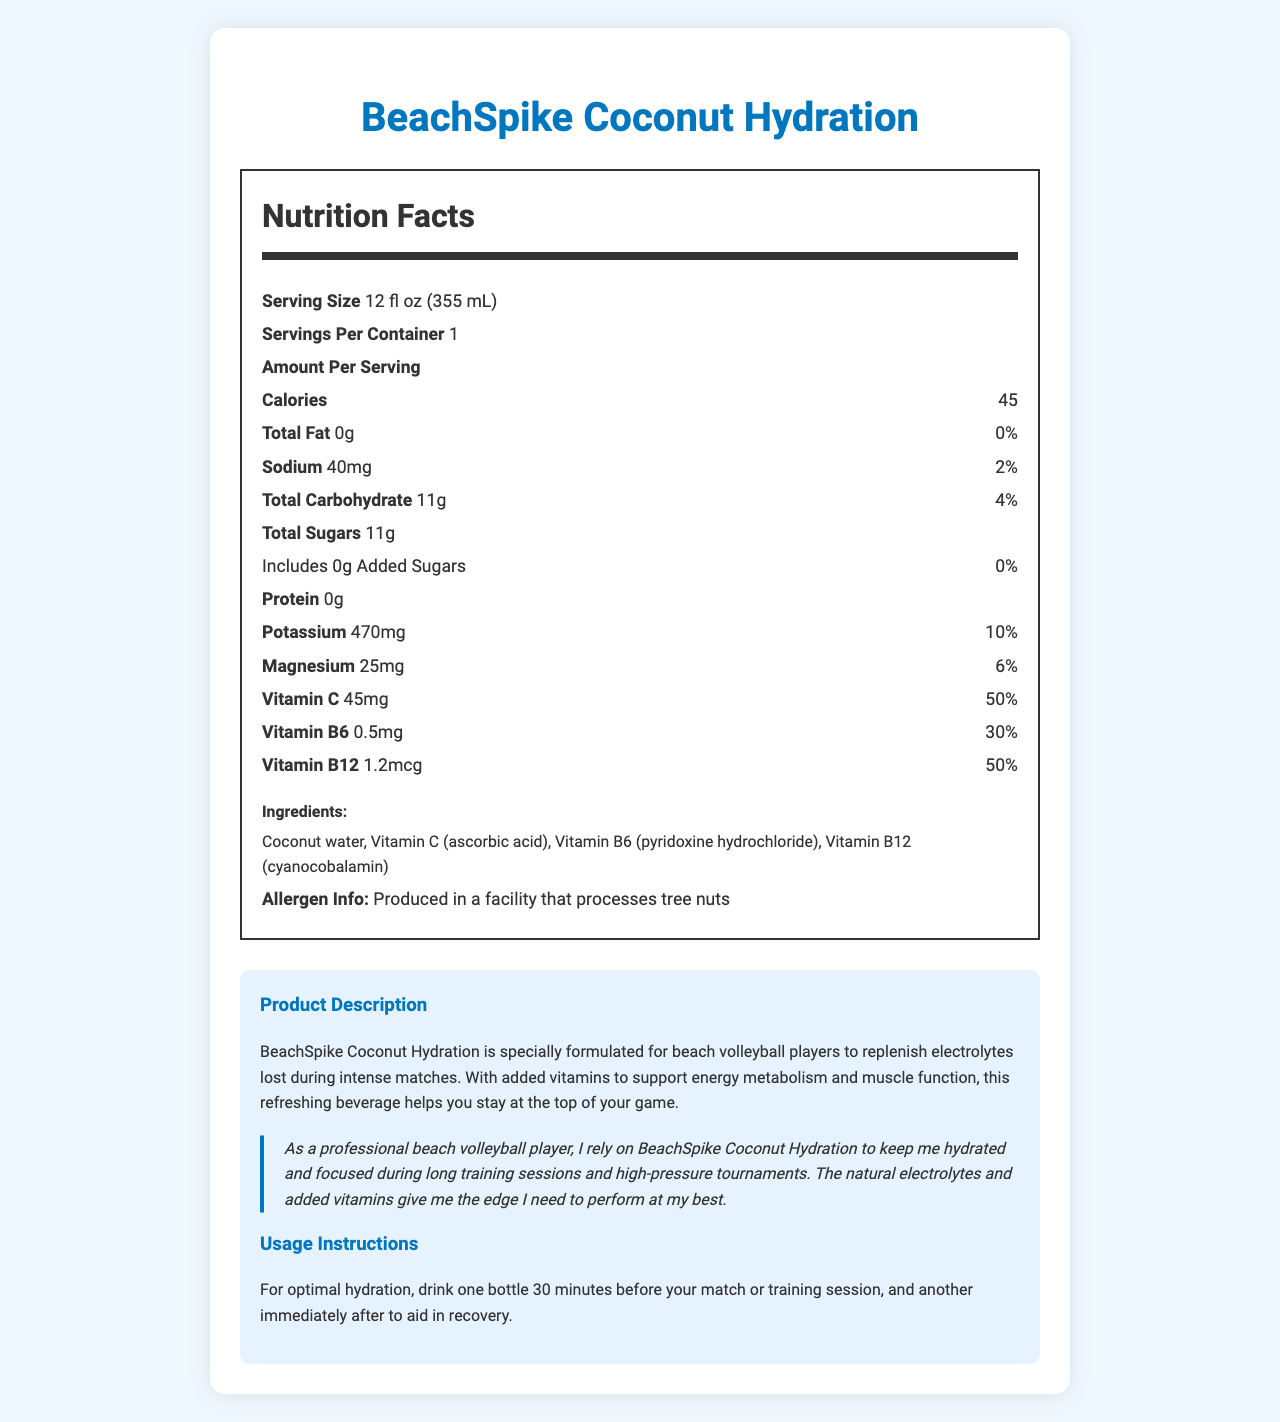what is the serving size? The serving size is listed near the top of the nutrition facts under the heading "Serving Size."
Answer: 12 fl oz (355 mL) how many servings are in one container? The number of servings per container is specified below the serving size, labeled as "Servings Per Container."
Answer: 1 what is the calorie count per serving? The calorie count per serving is clearly indicated just below the "Amount Per Serving" line, labeled as "Calories."
Answer: 45 calories what vitamins are included in this beverage? The vitamins included are listed under the nutrition facts section, with their respective amounts and daily values.
Answer: Vitamin C, Vitamin B6, Vitamin B12 how much sodium is in one serving? The amount of sodium in one serving is noted after the "Sodium" label in the nutrition facts section.
Answer: 40mg how much potassium is there per serving? The amount of potassium is specified next to "Potassium" under the nutrition facts, along with its daily value percentage.
Answer: 470mg what is the total carbohydrate amount per serving? A. 8g B. 10g C. 11g D. 12g The total carbohydrate amount per serving is listed as "Total Carbohydrate" in the nutrition facts section, showing 11g.
Answer: C. 11g what percentage of the daily recommended intake of Vitamin C does this beverage provide? A. 10% B. 25% C. 50% D. 75% The document lists Vitamin C with an amount of 45mg and a daily value of 50%.
Answer: C. 50% can individuals who are allergic to tree nuts consume this product safely? The product is produced in a facility that processes tree nuts, posing a potential risk of cross-contamination for people with tree nut allergies.
Answer: No what is the main purpose of this product? The product is described as being specially formulated for beach volleyball players to replenish electrolytes lost during intense matches and to support energy metabolism and muscle function.
Answer: Hydration and replenishing electrolytes for beach volleyball players does this beverage contain any added sugars? The nutrition facts indicate 0 grams of added sugars under the "Total Sugars" section.
Answer: No how much protein is in one serving of this beverage? The amount of protein per serving is listed as "Protein: 0g" in the nutrition facts.
Answer: 0g is the BeachSpike Coconut Hydration recommended to drink before or after matches? The usage instructions recommend drinking one bottle 30 minutes before the match or training session and another immediately after for recovery.
Answer: Both why might a professional beach volleyball player endorse this beverage? This information is provided in the athlete’s endorsement section where a professional beach volleyball player explains why they rely on BeachSpike Coconut Hydration.
Answer: The beverage helps keep them hydrated and focused during long training sessions and high-pressure tournaments. The natural electrolytes and added vitamins give them an edge in performance. summarize the main points of the nutrition facts label and product information. The label provides details on serving size, nutrient content, ingredients, and product usage instructions, making it clear that the beverage is geared toward athletic performance and hydration. The athlete endorsement underscores its effectiveness in a competitive setting.
Answer: BeachSpike Coconut Hydration is a beverage designed to hydrate and replenish electrolytes for beach volleyball players. It contains 45 calories per 12 fl oz serving, with no fat or protein, and 11g of carbohydrates. Important nutrients include 470mg of potassium, 25mg of magnesium, 45mg of Vitamin C, 0.5mg of Vitamin B6, and 1.2mcg of Vitamin B12. The beverage is made from coconut water and added vitamins, and is produced in a facility that processes tree nuts. The product is recommended to be consumed both before and after physical performance. is the list of ingredients present on the nutrition facts label sufficient to understand if there are any artificial additives? The document lists the ingredients but does not specify whether any of the listed vitamins or components are derived from natural or artificial sources.
Answer: Cannot be determined 